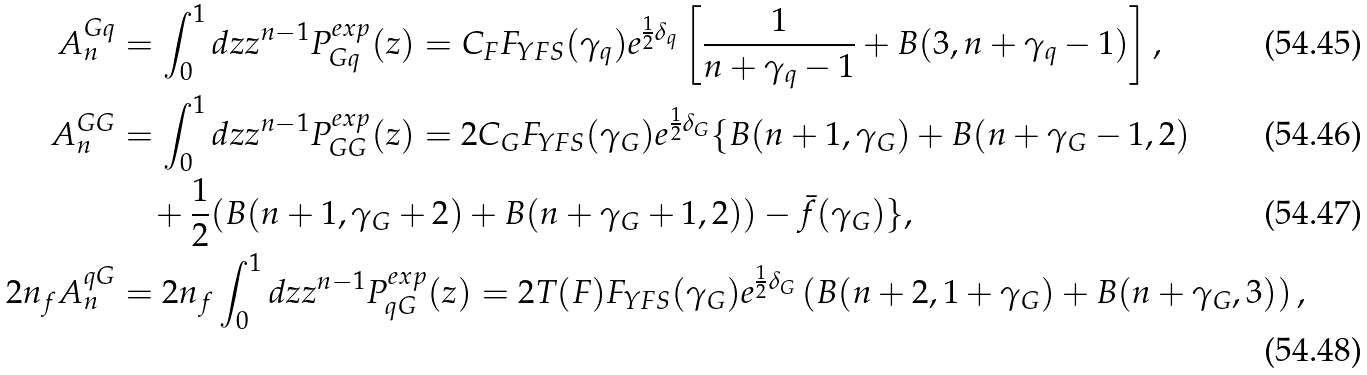Convert formula to latex. <formula><loc_0><loc_0><loc_500><loc_500>A ^ { G q } _ { n } & = \int _ { 0 } ^ { 1 } d z z ^ { n - 1 } P ^ { e x p } _ { G q } ( z ) = C _ { F } F _ { Y F S } ( \gamma _ { q } ) e ^ { \frac { 1 } { 2 } \delta _ { q } } \left [ \frac { 1 } { n + \gamma _ { q } - 1 } + B ( 3 , n + \gamma _ { q } - 1 ) \right ] , \\ A ^ { G G } _ { n } & = \int _ { 0 } ^ { 1 } d z z ^ { n - 1 } P ^ { e x p } _ { G G } ( z ) = 2 C _ { G } F _ { Y F S } ( \gamma _ { G } ) e ^ { \frac { 1 } { 2 } \delta _ { G } } \{ B ( n + 1 , \gamma _ { G } ) + B ( n + \gamma _ { G } - 1 , 2 ) \\ & \quad + \frac { 1 } { 2 } ( B ( n + 1 , \gamma _ { G } + 2 ) + B ( n + \gamma _ { G } + 1 , 2 ) ) - \bar { f } ( \gamma _ { G } ) \} , \\ 2 n _ { f } A ^ { q G } _ { n } & = 2 n _ { f } \int ^ { 1 } _ { 0 } d z z ^ { n - 1 } P ^ { e x p } _ { q G } ( z ) = 2 T ( F ) F _ { Y F S } ( \gamma _ { G } ) e ^ { \frac { 1 } { 2 } \delta _ { G } } \left ( B ( n + 2 , 1 + \gamma _ { G } ) + B ( n + \gamma _ { G } , 3 ) \right ) ,</formula> 